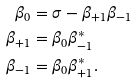Convert formula to latex. <formula><loc_0><loc_0><loc_500><loc_500>\beta _ { 0 } & = \sigma - \beta _ { + 1 } \beta _ { - 1 } \\ \beta _ { + 1 } & = \beta _ { 0 } \beta _ { - 1 } ^ { \ast } \\ \beta _ { - 1 } & = \beta _ { 0 } \beta _ { + 1 } ^ { \ast } .</formula> 